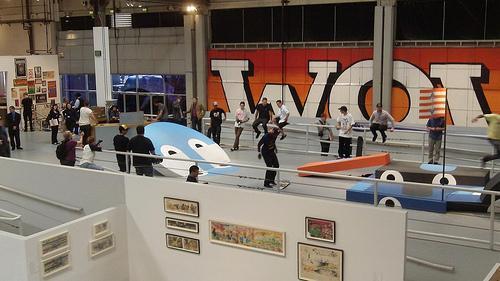How many framed pictures are in the foreground?
Give a very brief answer. 10. 